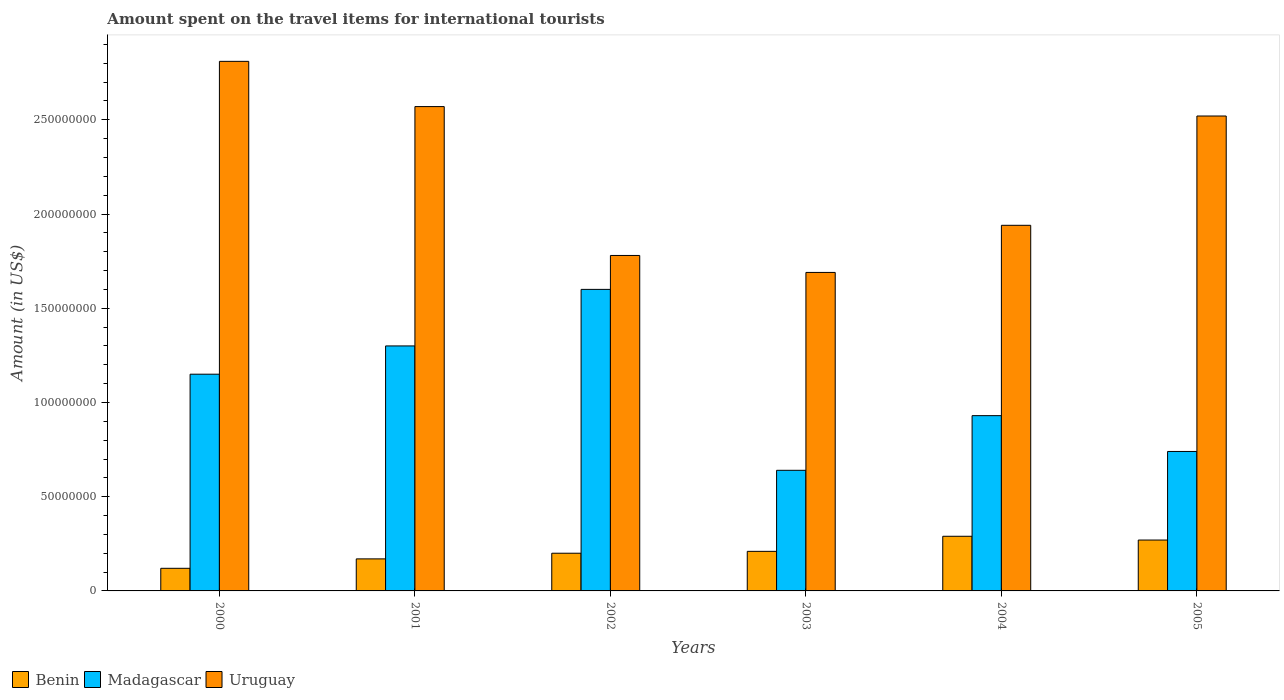Are the number of bars per tick equal to the number of legend labels?
Provide a short and direct response. Yes. Are the number of bars on each tick of the X-axis equal?
Provide a short and direct response. Yes. How many bars are there on the 1st tick from the left?
Offer a very short reply. 3. What is the amount spent on the travel items for international tourists in Uruguay in 2002?
Ensure brevity in your answer.  1.78e+08. Across all years, what is the maximum amount spent on the travel items for international tourists in Uruguay?
Offer a terse response. 2.81e+08. In which year was the amount spent on the travel items for international tourists in Benin maximum?
Offer a terse response. 2004. In which year was the amount spent on the travel items for international tourists in Uruguay minimum?
Offer a terse response. 2003. What is the total amount spent on the travel items for international tourists in Madagascar in the graph?
Give a very brief answer. 6.36e+08. What is the difference between the amount spent on the travel items for international tourists in Benin in 2000 and that in 2004?
Provide a succinct answer. -1.70e+07. What is the difference between the amount spent on the travel items for international tourists in Benin in 2001 and the amount spent on the travel items for international tourists in Uruguay in 2004?
Your answer should be compact. -1.77e+08. What is the average amount spent on the travel items for international tourists in Madagascar per year?
Provide a short and direct response. 1.06e+08. In the year 2003, what is the difference between the amount spent on the travel items for international tourists in Madagascar and amount spent on the travel items for international tourists in Uruguay?
Your answer should be very brief. -1.05e+08. What is the ratio of the amount spent on the travel items for international tourists in Madagascar in 2002 to that in 2005?
Give a very brief answer. 2.16. What is the difference between the highest and the lowest amount spent on the travel items for international tourists in Madagascar?
Ensure brevity in your answer.  9.60e+07. In how many years, is the amount spent on the travel items for international tourists in Benin greater than the average amount spent on the travel items for international tourists in Benin taken over all years?
Your response must be concise. 2. What does the 1st bar from the left in 2005 represents?
Your answer should be compact. Benin. What does the 2nd bar from the right in 2002 represents?
Give a very brief answer. Madagascar. Are the values on the major ticks of Y-axis written in scientific E-notation?
Offer a terse response. No. How many legend labels are there?
Ensure brevity in your answer.  3. How are the legend labels stacked?
Provide a short and direct response. Horizontal. What is the title of the graph?
Offer a terse response. Amount spent on the travel items for international tourists. Does "Iraq" appear as one of the legend labels in the graph?
Make the answer very short. No. What is the label or title of the Y-axis?
Offer a terse response. Amount (in US$). What is the Amount (in US$) of Madagascar in 2000?
Offer a very short reply. 1.15e+08. What is the Amount (in US$) of Uruguay in 2000?
Keep it short and to the point. 2.81e+08. What is the Amount (in US$) in Benin in 2001?
Offer a very short reply. 1.70e+07. What is the Amount (in US$) of Madagascar in 2001?
Your answer should be very brief. 1.30e+08. What is the Amount (in US$) in Uruguay in 2001?
Offer a terse response. 2.57e+08. What is the Amount (in US$) of Madagascar in 2002?
Offer a terse response. 1.60e+08. What is the Amount (in US$) of Uruguay in 2002?
Offer a very short reply. 1.78e+08. What is the Amount (in US$) of Benin in 2003?
Your response must be concise. 2.10e+07. What is the Amount (in US$) of Madagascar in 2003?
Give a very brief answer. 6.40e+07. What is the Amount (in US$) of Uruguay in 2003?
Make the answer very short. 1.69e+08. What is the Amount (in US$) of Benin in 2004?
Ensure brevity in your answer.  2.90e+07. What is the Amount (in US$) of Madagascar in 2004?
Give a very brief answer. 9.30e+07. What is the Amount (in US$) in Uruguay in 2004?
Your response must be concise. 1.94e+08. What is the Amount (in US$) of Benin in 2005?
Ensure brevity in your answer.  2.70e+07. What is the Amount (in US$) of Madagascar in 2005?
Offer a terse response. 7.40e+07. What is the Amount (in US$) in Uruguay in 2005?
Provide a succinct answer. 2.52e+08. Across all years, what is the maximum Amount (in US$) of Benin?
Offer a terse response. 2.90e+07. Across all years, what is the maximum Amount (in US$) of Madagascar?
Your response must be concise. 1.60e+08. Across all years, what is the maximum Amount (in US$) of Uruguay?
Keep it short and to the point. 2.81e+08. Across all years, what is the minimum Amount (in US$) of Madagascar?
Provide a short and direct response. 6.40e+07. Across all years, what is the minimum Amount (in US$) in Uruguay?
Your response must be concise. 1.69e+08. What is the total Amount (in US$) of Benin in the graph?
Keep it short and to the point. 1.26e+08. What is the total Amount (in US$) of Madagascar in the graph?
Offer a very short reply. 6.36e+08. What is the total Amount (in US$) of Uruguay in the graph?
Keep it short and to the point. 1.33e+09. What is the difference between the Amount (in US$) in Benin in 2000 and that in 2001?
Keep it short and to the point. -5.00e+06. What is the difference between the Amount (in US$) in Madagascar in 2000 and that in 2001?
Your response must be concise. -1.50e+07. What is the difference between the Amount (in US$) of Uruguay in 2000 and that in 2001?
Give a very brief answer. 2.40e+07. What is the difference between the Amount (in US$) of Benin in 2000 and that in 2002?
Provide a succinct answer. -8.00e+06. What is the difference between the Amount (in US$) of Madagascar in 2000 and that in 2002?
Offer a terse response. -4.50e+07. What is the difference between the Amount (in US$) in Uruguay in 2000 and that in 2002?
Make the answer very short. 1.03e+08. What is the difference between the Amount (in US$) in Benin in 2000 and that in 2003?
Give a very brief answer. -9.00e+06. What is the difference between the Amount (in US$) in Madagascar in 2000 and that in 2003?
Your answer should be very brief. 5.10e+07. What is the difference between the Amount (in US$) of Uruguay in 2000 and that in 2003?
Your response must be concise. 1.12e+08. What is the difference between the Amount (in US$) of Benin in 2000 and that in 2004?
Provide a short and direct response. -1.70e+07. What is the difference between the Amount (in US$) in Madagascar in 2000 and that in 2004?
Provide a short and direct response. 2.20e+07. What is the difference between the Amount (in US$) in Uruguay in 2000 and that in 2004?
Your answer should be very brief. 8.70e+07. What is the difference between the Amount (in US$) in Benin in 2000 and that in 2005?
Ensure brevity in your answer.  -1.50e+07. What is the difference between the Amount (in US$) of Madagascar in 2000 and that in 2005?
Offer a terse response. 4.10e+07. What is the difference between the Amount (in US$) of Uruguay in 2000 and that in 2005?
Your answer should be compact. 2.90e+07. What is the difference between the Amount (in US$) of Benin in 2001 and that in 2002?
Provide a short and direct response. -3.00e+06. What is the difference between the Amount (in US$) in Madagascar in 2001 and that in 2002?
Your answer should be compact. -3.00e+07. What is the difference between the Amount (in US$) of Uruguay in 2001 and that in 2002?
Provide a succinct answer. 7.90e+07. What is the difference between the Amount (in US$) of Benin in 2001 and that in 2003?
Offer a terse response. -4.00e+06. What is the difference between the Amount (in US$) of Madagascar in 2001 and that in 2003?
Your answer should be compact. 6.60e+07. What is the difference between the Amount (in US$) of Uruguay in 2001 and that in 2003?
Provide a succinct answer. 8.80e+07. What is the difference between the Amount (in US$) in Benin in 2001 and that in 2004?
Provide a succinct answer. -1.20e+07. What is the difference between the Amount (in US$) in Madagascar in 2001 and that in 2004?
Provide a succinct answer. 3.70e+07. What is the difference between the Amount (in US$) in Uruguay in 2001 and that in 2004?
Give a very brief answer. 6.30e+07. What is the difference between the Amount (in US$) in Benin in 2001 and that in 2005?
Offer a very short reply. -1.00e+07. What is the difference between the Amount (in US$) in Madagascar in 2001 and that in 2005?
Offer a very short reply. 5.60e+07. What is the difference between the Amount (in US$) of Benin in 2002 and that in 2003?
Provide a short and direct response. -1.00e+06. What is the difference between the Amount (in US$) of Madagascar in 2002 and that in 2003?
Keep it short and to the point. 9.60e+07. What is the difference between the Amount (in US$) of Uruguay in 2002 and that in 2003?
Your response must be concise. 9.00e+06. What is the difference between the Amount (in US$) in Benin in 2002 and that in 2004?
Ensure brevity in your answer.  -9.00e+06. What is the difference between the Amount (in US$) in Madagascar in 2002 and that in 2004?
Your answer should be compact. 6.70e+07. What is the difference between the Amount (in US$) in Uruguay in 2002 and that in 2004?
Give a very brief answer. -1.60e+07. What is the difference between the Amount (in US$) in Benin in 2002 and that in 2005?
Make the answer very short. -7.00e+06. What is the difference between the Amount (in US$) in Madagascar in 2002 and that in 2005?
Provide a succinct answer. 8.60e+07. What is the difference between the Amount (in US$) in Uruguay in 2002 and that in 2005?
Provide a short and direct response. -7.40e+07. What is the difference between the Amount (in US$) in Benin in 2003 and that in 2004?
Keep it short and to the point. -8.00e+06. What is the difference between the Amount (in US$) of Madagascar in 2003 and that in 2004?
Your answer should be very brief. -2.90e+07. What is the difference between the Amount (in US$) in Uruguay in 2003 and that in 2004?
Give a very brief answer. -2.50e+07. What is the difference between the Amount (in US$) in Benin in 2003 and that in 2005?
Offer a very short reply. -6.00e+06. What is the difference between the Amount (in US$) of Madagascar in 2003 and that in 2005?
Offer a terse response. -1.00e+07. What is the difference between the Amount (in US$) of Uruguay in 2003 and that in 2005?
Your answer should be compact. -8.30e+07. What is the difference between the Amount (in US$) of Benin in 2004 and that in 2005?
Keep it short and to the point. 2.00e+06. What is the difference between the Amount (in US$) of Madagascar in 2004 and that in 2005?
Your response must be concise. 1.90e+07. What is the difference between the Amount (in US$) in Uruguay in 2004 and that in 2005?
Your response must be concise. -5.80e+07. What is the difference between the Amount (in US$) of Benin in 2000 and the Amount (in US$) of Madagascar in 2001?
Your response must be concise. -1.18e+08. What is the difference between the Amount (in US$) in Benin in 2000 and the Amount (in US$) in Uruguay in 2001?
Your answer should be compact. -2.45e+08. What is the difference between the Amount (in US$) in Madagascar in 2000 and the Amount (in US$) in Uruguay in 2001?
Your response must be concise. -1.42e+08. What is the difference between the Amount (in US$) in Benin in 2000 and the Amount (in US$) in Madagascar in 2002?
Provide a short and direct response. -1.48e+08. What is the difference between the Amount (in US$) in Benin in 2000 and the Amount (in US$) in Uruguay in 2002?
Your answer should be very brief. -1.66e+08. What is the difference between the Amount (in US$) of Madagascar in 2000 and the Amount (in US$) of Uruguay in 2002?
Provide a short and direct response. -6.30e+07. What is the difference between the Amount (in US$) in Benin in 2000 and the Amount (in US$) in Madagascar in 2003?
Offer a very short reply. -5.20e+07. What is the difference between the Amount (in US$) in Benin in 2000 and the Amount (in US$) in Uruguay in 2003?
Your answer should be very brief. -1.57e+08. What is the difference between the Amount (in US$) in Madagascar in 2000 and the Amount (in US$) in Uruguay in 2003?
Keep it short and to the point. -5.40e+07. What is the difference between the Amount (in US$) of Benin in 2000 and the Amount (in US$) of Madagascar in 2004?
Your response must be concise. -8.10e+07. What is the difference between the Amount (in US$) in Benin in 2000 and the Amount (in US$) in Uruguay in 2004?
Make the answer very short. -1.82e+08. What is the difference between the Amount (in US$) in Madagascar in 2000 and the Amount (in US$) in Uruguay in 2004?
Offer a very short reply. -7.90e+07. What is the difference between the Amount (in US$) of Benin in 2000 and the Amount (in US$) of Madagascar in 2005?
Your answer should be very brief. -6.20e+07. What is the difference between the Amount (in US$) of Benin in 2000 and the Amount (in US$) of Uruguay in 2005?
Ensure brevity in your answer.  -2.40e+08. What is the difference between the Amount (in US$) of Madagascar in 2000 and the Amount (in US$) of Uruguay in 2005?
Your answer should be very brief. -1.37e+08. What is the difference between the Amount (in US$) of Benin in 2001 and the Amount (in US$) of Madagascar in 2002?
Provide a short and direct response. -1.43e+08. What is the difference between the Amount (in US$) in Benin in 2001 and the Amount (in US$) in Uruguay in 2002?
Offer a terse response. -1.61e+08. What is the difference between the Amount (in US$) of Madagascar in 2001 and the Amount (in US$) of Uruguay in 2002?
Provide a short and direct response. -4.80e+07. What is the difference between the Amount (in US$) in Benin in 2001 and the Amount (in US$) in Madagascar in 2003?
Offer a terse response. -4.70e+07. What is the difference between the Amount (in US$) of Benin in 2001 and the Amount (in US$) of Uruguay in 2003?
Provide a short and direct response. -1.52e+08. What is the difference between the Amount (in US$) in Madagascar in 2001 and the Amount (in US$) in Uruguay in 2003?
Your answer should be very brief. -3.90e+07. What is the difference between the Amount (in US$) of Benin in 2001 and the Amount (in US$) of Madagascar in 2004?
Provide a short and direct response. -7.60e+07. What is the difference between the Amount (in US$) in Benin in 2001 and the Amount (in US$) in Uruguay in 2004?
Give a very brief answer. -1.77e+08. What is the difference between the Amount (in US$) in Madagascar in 2001 and the Amount (in US$) in Uruguay in 2004?
Offer a very short reply. -6.40e+07. What is the difference between the Amount (in US$) of Benin in 2001 and the Amount (in US$) of Madagascar in 2005?
Make the answer very short. -5.70e+07. What is the difference between the Amount (in US$) of Benin in 2001 and the Amount (in US$) of Uruguay in 2005?
Give a very brief answer. -2.35e+08. What is the difference between the Amount (in US$) of Madagascar in 2001 and the Amount (in US$) of Uruguay in 2005?
Ensure brevity in your answer.  -1.22e+08. What is the difference between the Amount (in US$) of Benin in 2002 and the Amount (in US$) of Madagascar in 2003?
Your answer should be compact. -4.40e+07. What is the difference between the Amount (in US$) of Benin in 2002 and the Amount (in US$) of Uruguay in 2003?
Keep it short and to the point. -1.49e+08. What is the difference between the Amount (in US$) in Madagascar in 2002 and the Amount (in US$) in Uruguay in 2003?
Your answer should be compact. -9.00e+06. What is the difference between the Amount (in US$) in Benin in 2002 and the Amount (in US$) in Madagascar in 2004?
Offer a very short reply. -7.30e+07. What is the difference between the Amount (in US$) of Benin in 2002 and the Amount (in US$) of Uruguay in 2004?
Ensure brevity in your answer.  -1.74e+08. What is the difference between the Amount (in US$) in Madagascar in 2002 and the Amount (in US$) in Uruguay in 2004?
Offer a very short reply. -3.40e+07. What is the difference between the Amount (in US$) in Benin in 2002 and the Amount (in US$) in Madagascar in 2005?
Your response must be concise. -5.40e+07. What is the difference between the Amount (in US$) of Benin in 2002 and the Amount (in US$) of Uruguay in 2005?
Ensure brevity in your answer.  -2.32e+08. What is the difference between the Amount (in US$) of Madagascar in 2002 and the Amount (in US$) of Uruguay in 2005?
Provide a succinct answer. -9.20e+07. What is the difference between the Amount (in US$) in Benin in 2003 and the Amount (in US$) in Madagascar in 2004?
Make the answer very short. -7.20e+07. What is the difference between the Amount (in US$) in Benin in 2003 and the Amount (in US$) in Uruguay in 2004?
Offer a very short reply. -1.73e+08. What is the difference between the Amount (in US$) in Madagascar in 2003 and the Amount (in US$) in Uruguay in 2004?
Provide a succinct answer. -1.30e+08. What is the difference between the Amount (in US$) in Benin in 2003 and the Amount (in US$) in Madagascar in 2005?
Ensure brevity in your answer.  -5.30e+07. What is the difference between the Amount (in US$) in Benin in 2003 and the Amount (in US$) in Uruguay in 2005?
Provide a succinct answer. -2.31e+08. What is the difference between the Amount (in US$) in Madagascar in 2003 and the Amount (in US$) in Uruguay in 2005?
Your response must be concise. -1.88e+08. What is the difference between the Amount (in US$) of Benin in 2004 and the Amount (in US$) of Madagascar in 2005?
Give a very brief answer. -4.50e+07. What is the difference between the Amount (in US$) of Benin in 2004 and the Amount (in US$) of Uruguay in 2005?
Keep it short and to the point. -2.23e+08. What is the difference between the Amount (in US$) of Madagascar in 2004 and the Amount (in US$) of Uruguay in 2005?
Give a very brief answer. -1.59e+08. What is the average Amount (in US$) of Benin per year?
Provide a succinct answer. 2.10e+07. What is the average Amount (in US$) of Madagascar per year?
Offer a very short reply. 1.06e+08. What is the average Amount (in US$) in Uruguay per year?
Keep it short and to the point. 2.22e+08. In the year 2000, what is the difference between the Amount (in US$) of Benin and Amount (in US$) of Madagascar?
Give a very brief answer. -1.03e+08. In the year 2000, what is the difference between the Amount (in US$) in Benin and Amount (in US$) in Uruguay?
Your answer should be very brief. -2.69e+08. In the year 2000, what is the difference between the Amount (in US$) in Madagascar and Amount (in US$) in Uruguay?
Give a very brief answer. -1.66e+08. In the year 2001, what is the difference between the Amount (in US$) of Benin and Amount (in US$) of Madagascar?
Give a very brief answer. -1.13e+08. In the year 2001, what is the difference between the Amount (in US$) of Benin and Amount (in US$) of Uruguay?
Make the answer very short. -2.40e+08. In the year 2001, what is the difference between the Amount (in US$) of Madagascar and Amount (in US$) of Uruguay?
Give a very brief answer. -1.27e+08. In the year 2002, what is the difference between the Amount (in US$) in Benin and Amount (in US$) in Madagascar?
Make the answer very short. -1.40e+08. In the year 2002, what is the difference between the Amount (in US$) of Benin and Amount (in US$) of Uruguay?
Offer a very short reply. -1.58e+08. In the year 2002, what is the difference between the Amount (in US$) in Madagascar and Amount (in US$) in Uruguay?
Make the answer very short. -1.80e+07. In the year 2003, what is the difference between the Amount (in US$) in Benin and Amount (in US$) in Madagascar?
Provide a short and direct response. -4.30e+07. In the year 2003, what is the difference between the Amount (in US$) of Benin and Amount (in US$) of Uruguay?
Your answer should be very brief. -1.48e+08. In the year 2003, what is the difference between the Amount (in US$) of Madagascar and Amount (in US$) of Uruguay?
Give a very brief answer. -1.05e+08. In the year 2004, what is the difference between the Amount (in US$) of Benin and Amount (in US$) of Madagascar?
Provide a short and direct response. -6.40e+07. In the year 2004, what is the difference between the Amount (in US$) in Benin and Amount (in US$) in Uruguay?
Your answer should be compact. -1.65e+08. In the year 2004, what is the difference between the Amount (in US$) in Madagascar and Amount (in US$) in Uruguay?
Make the answer very short. -1.01e+08. In the year 2005, what is the difference between the Amount (in US$) of Benin and Amount (in US$) of Madagascar?
Provide a succinct answer. -4.70e+07. In the year 2005, what is the difference between the Amount (in US$) of Benin and Amount (in US$) of Uruguay?
Make the answer very short. -2.25e+08. In the year 2005, what is the difference between the Amount (in US$) in Madagascar and Amount (in US$) in Uruguay?
Give a very brief answer. -1.78e+08. What is the ratio of the Amount (in US$) in Benin in 2000 to that in 2001?
Make the answer very short. 0.71. What is the ratio of the Amount (in US$) of Madagascar in 2000 to that in 2001?
Provide a short and direct response. 0.88. What is the ratio of the Amount (in US$) of Uruguay in 2000 to that in 2001?
Offer a very short reply. 1.09. What is the ratio of the Amount (in US$) in Benin in 2000 to that in 2002?
Give a very brief answer. 0.6. What is the ratio of the Amount (in US$) of Madagascar in 2000 to that in 2002?
Your answer should be compact. 0.72. What is the ratio of the Amount (in US$) in Uruguay in 2000 to that in 2002?
Provide a short and direct response. 1.58. What is the ratio of the Amount (in US$) of Madagascar in 2000 to that in 2003?
Keep it short and to the point. 1.8. What is the ratio of the Amount (in US$) in Uruguay in 2000 to that in 2003?
Your response must be concise. 1.66. What is the ratio of the Amount (in US$) of Benin in 2000 to that in 2004?
Make the answer very short. 0.41. What is the ratio of the Amount (in US$) of Madagascar in 2000 to that in 2004?
Keep it short and to the point. 1.24. What is the ratio of the Amount (in US$) in Uruguay in 2000 to that in 2004?
Your answer should be compact. 1.45. What is the ratio of the Amount (in US$) in Benin in 2000 to that in 2005?
Give a very brief answer. 0.44. What is the ratio of the Amount (in US$) in Madagascar in 2000 to that in 2005?
Your response must be concise. 1.55. What is the ratio of the Amount (in US$) of Uruguay in 2000 to that in 2005?
Provide a short and direct response. 1.12. What is the ratio of the Amount (in US$) in Madagascar in 2001 to that in 2002?
Your answer should be compact. 0.81. What is the ratio of the Amount (in US$) of Uruguay in 2001 to that in 2002?
Your answer should be compact. 1.44. What is the ratio of the Amount (in US$) of Benin in 2001 to that in 2003?
Offer a terse response. 0.81. What is the ratio of the Amount (in US$) in Madagascar in 2001 to that in 2003?
Your answer should be compact. 2.03. What is the ratio of the Amount (in US$) of Uruguay in 2001 to that in 2003?
Provide a short and direct response. 1.52. What is the ratio of the Amount (in US$) of Benin in 2001 to that in 2004?
Provide a short and direct response. 0.59. What is the ratio of the Amount (in US$) of Madagascar in 2001 to that in 2004?
Make the answer very short. 1.4. What is the ratio of the Amount (in US$) in Uruguay in 2001 to that in 2004?
Provide a short and direct response. 1.32. What is the ratio of the Amount (in US$) of Benin in 2001 to that in 2005?
Provide a succinct answer. 0.63. What is the ratio of the Amount (in US$) of Madagascar in 2001 to that in 2005?
Offer a terse response. 1.76. What is the ratio of the Amount (in US$) of Uruguay in 2001 to that in 2005?
Your response must be concise. 1.02. What is the ratio of the Amount (in US$) in Madagascar in 2002 to that in 2003?
Your answer should be compact. 2.5. What is the ratio of the Amount (in US$) of Uruguay in 2002 to that in 2003?
Offer a very short reply. 1.05. What is the ratio of the Amount (in US$) in Benin in 2002 to that in 2004?
Give a very brief answer. 0.69. What is the ratio of the Amount (in US$) in Madagascar in 2002 to that in 2004?
Provide a succinct answer. 1.72. What is the ratio of the Amount (in US$) in Uruguay in 2002 to that in 2004?
Your answer should be very brief. 0.92. What is the ratio of the Amount (in US$) of Benin in 2002 to that in 2005?
Make the answer very short. 0.74. What is the ratio of the Amount (in US$) in Madagascar in 2002 to that in 2005?
Ensure brevity in your answer.  2.16. What is the ratio of the Amount (in US$) of Uruguay in 2002 to that in 2005?
Your answer should be very brief. 0.71. What is the ratio of the Amount (in US$) in Benin in 2003 to that in 2004?
Ensure brevity in your answer.  0.72. What is the ratio of the Amount (in US$) of Madagascar in 2003 to that in 2004?
Provide a succinct answer. 0.69. What is the ratio of the Amount (in US$) of Uruguay in 2003 to that in 2004?
Keep it short and to the point. 0.87. What is the ratio of the Amount (in US$) in Madagascar in 2003 to that in 2005?
Your response must be concise. 0.86. What is the ratio of the Amount (in US$) of Uruguay in 2003 to that in 2005?
Ensure brevity in your answer.  0.67. What is the ratio of the Amount (in US$) of Benin in 2004 to that in 2005?
Your answer should be very brief. 1.07. What is the ratio of the Amount (in US$) in Madagascar in 2004 to that in 2005?
Offer a very short reply. 1.26. What is the ratio of the Amount (in US$) in Uruguay in 2004 to that in 2005?
Offer a terse response. 0.77. What is the difference between the highest and the second highest Amount (in US$) in Benin?
Your answer should be very brief. 2.00e+06. What is the difference between the highest and the second highest Amount (in US$) in Madagascar?
Your answer should be compact. 3.00e+07. What is the difference between the highest and the second highest Amount (in US$) in Uruguay?
Offer a terse response. 2.40e+07. What is the difference between the highest and the lowest Amount (in US$) of Benin?
Ensure brevity in your answer.  1.70e+07. What is the difference between the highest and the lowest Amount (in US$) in Madagascar?
Your answer should be very brief. 9.60e+07. What is the difference between the highest and the lowest Amount (in US$) of Uruguay?
Your response must be concise. 1.12e+08. 